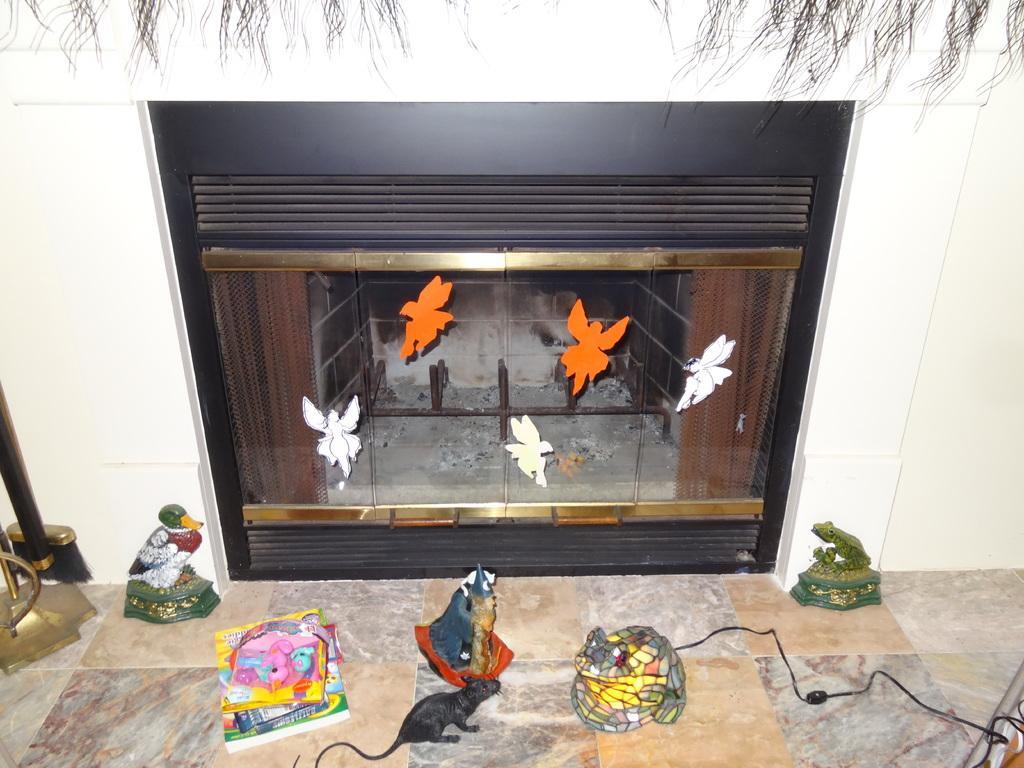Describe this image in one or two sentences. In this picture I can observe a fireplace in the house. There are some stickers stuck on the glass. I can observe some toys placed on the floor. In the background there is a wall. 